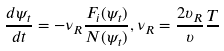Convert formula to latex. <formula><loc_0><loc_0><loc_500><loc_500>\frac { d \psi _ { t } } { d t } = - \nu _ { R } \frac { F _ { i } ( \psi _ { t } ) } { N ( \psi _ { t } ) } , \nu _ { R } = \frac { 2 \upsilon _ { R } } { \upsilon } \frac { T } { }</formula> 